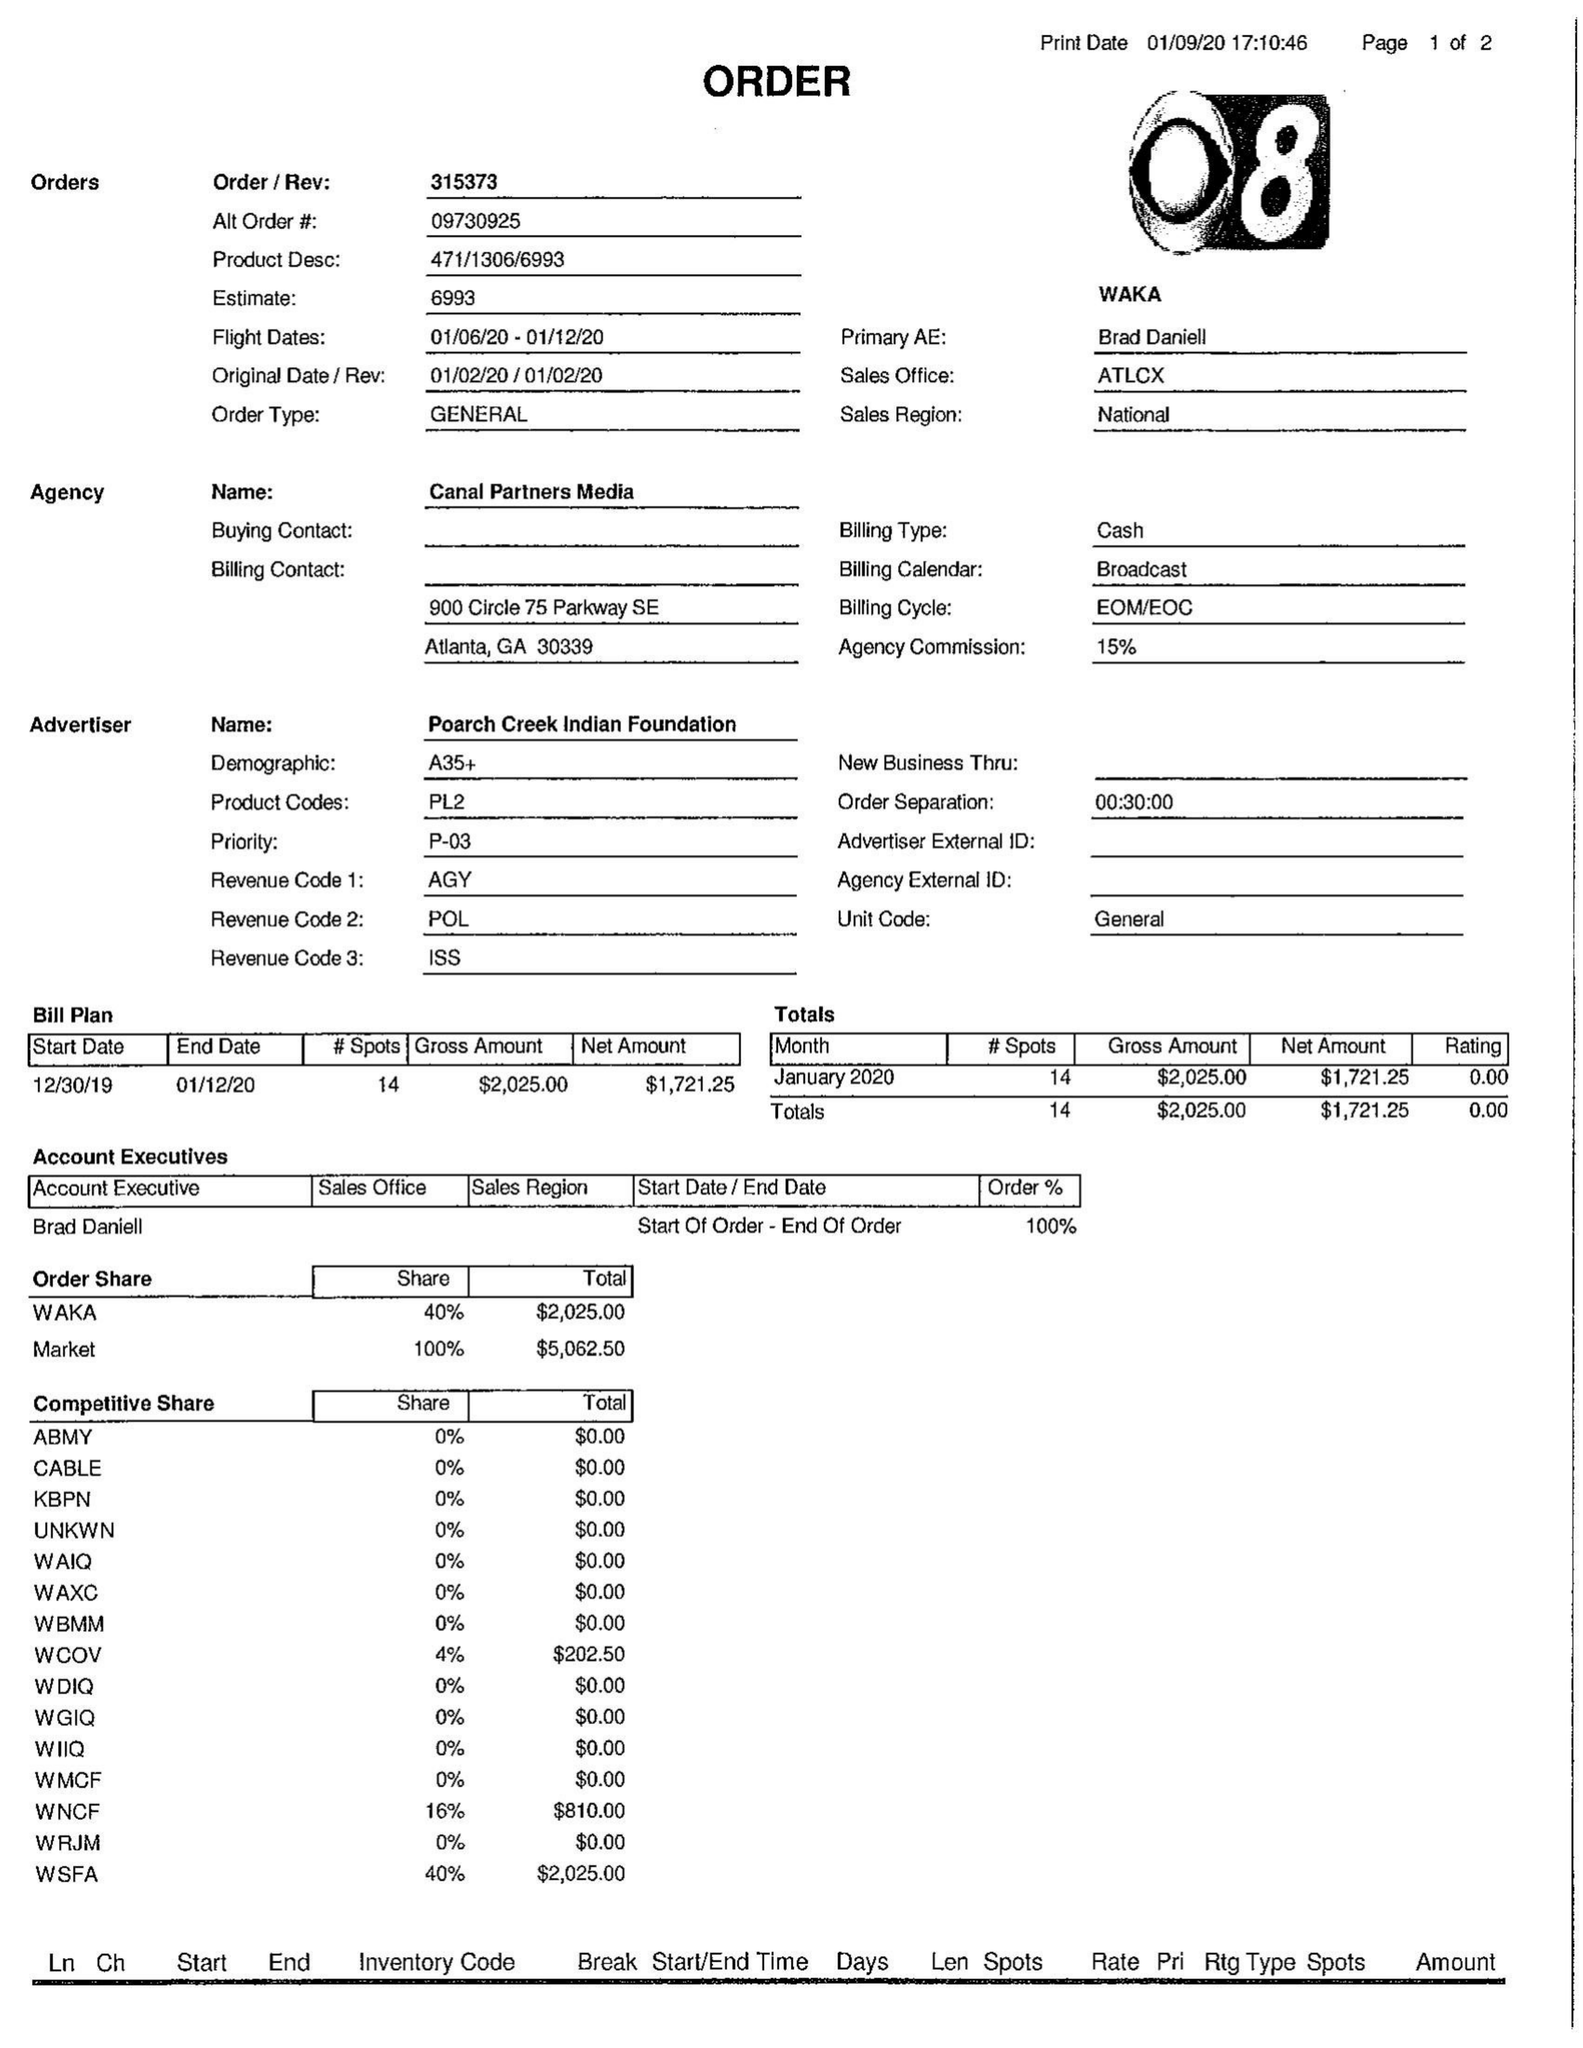What is the value for the contract_num?
Answer the question using a single word or phrase. 315373 